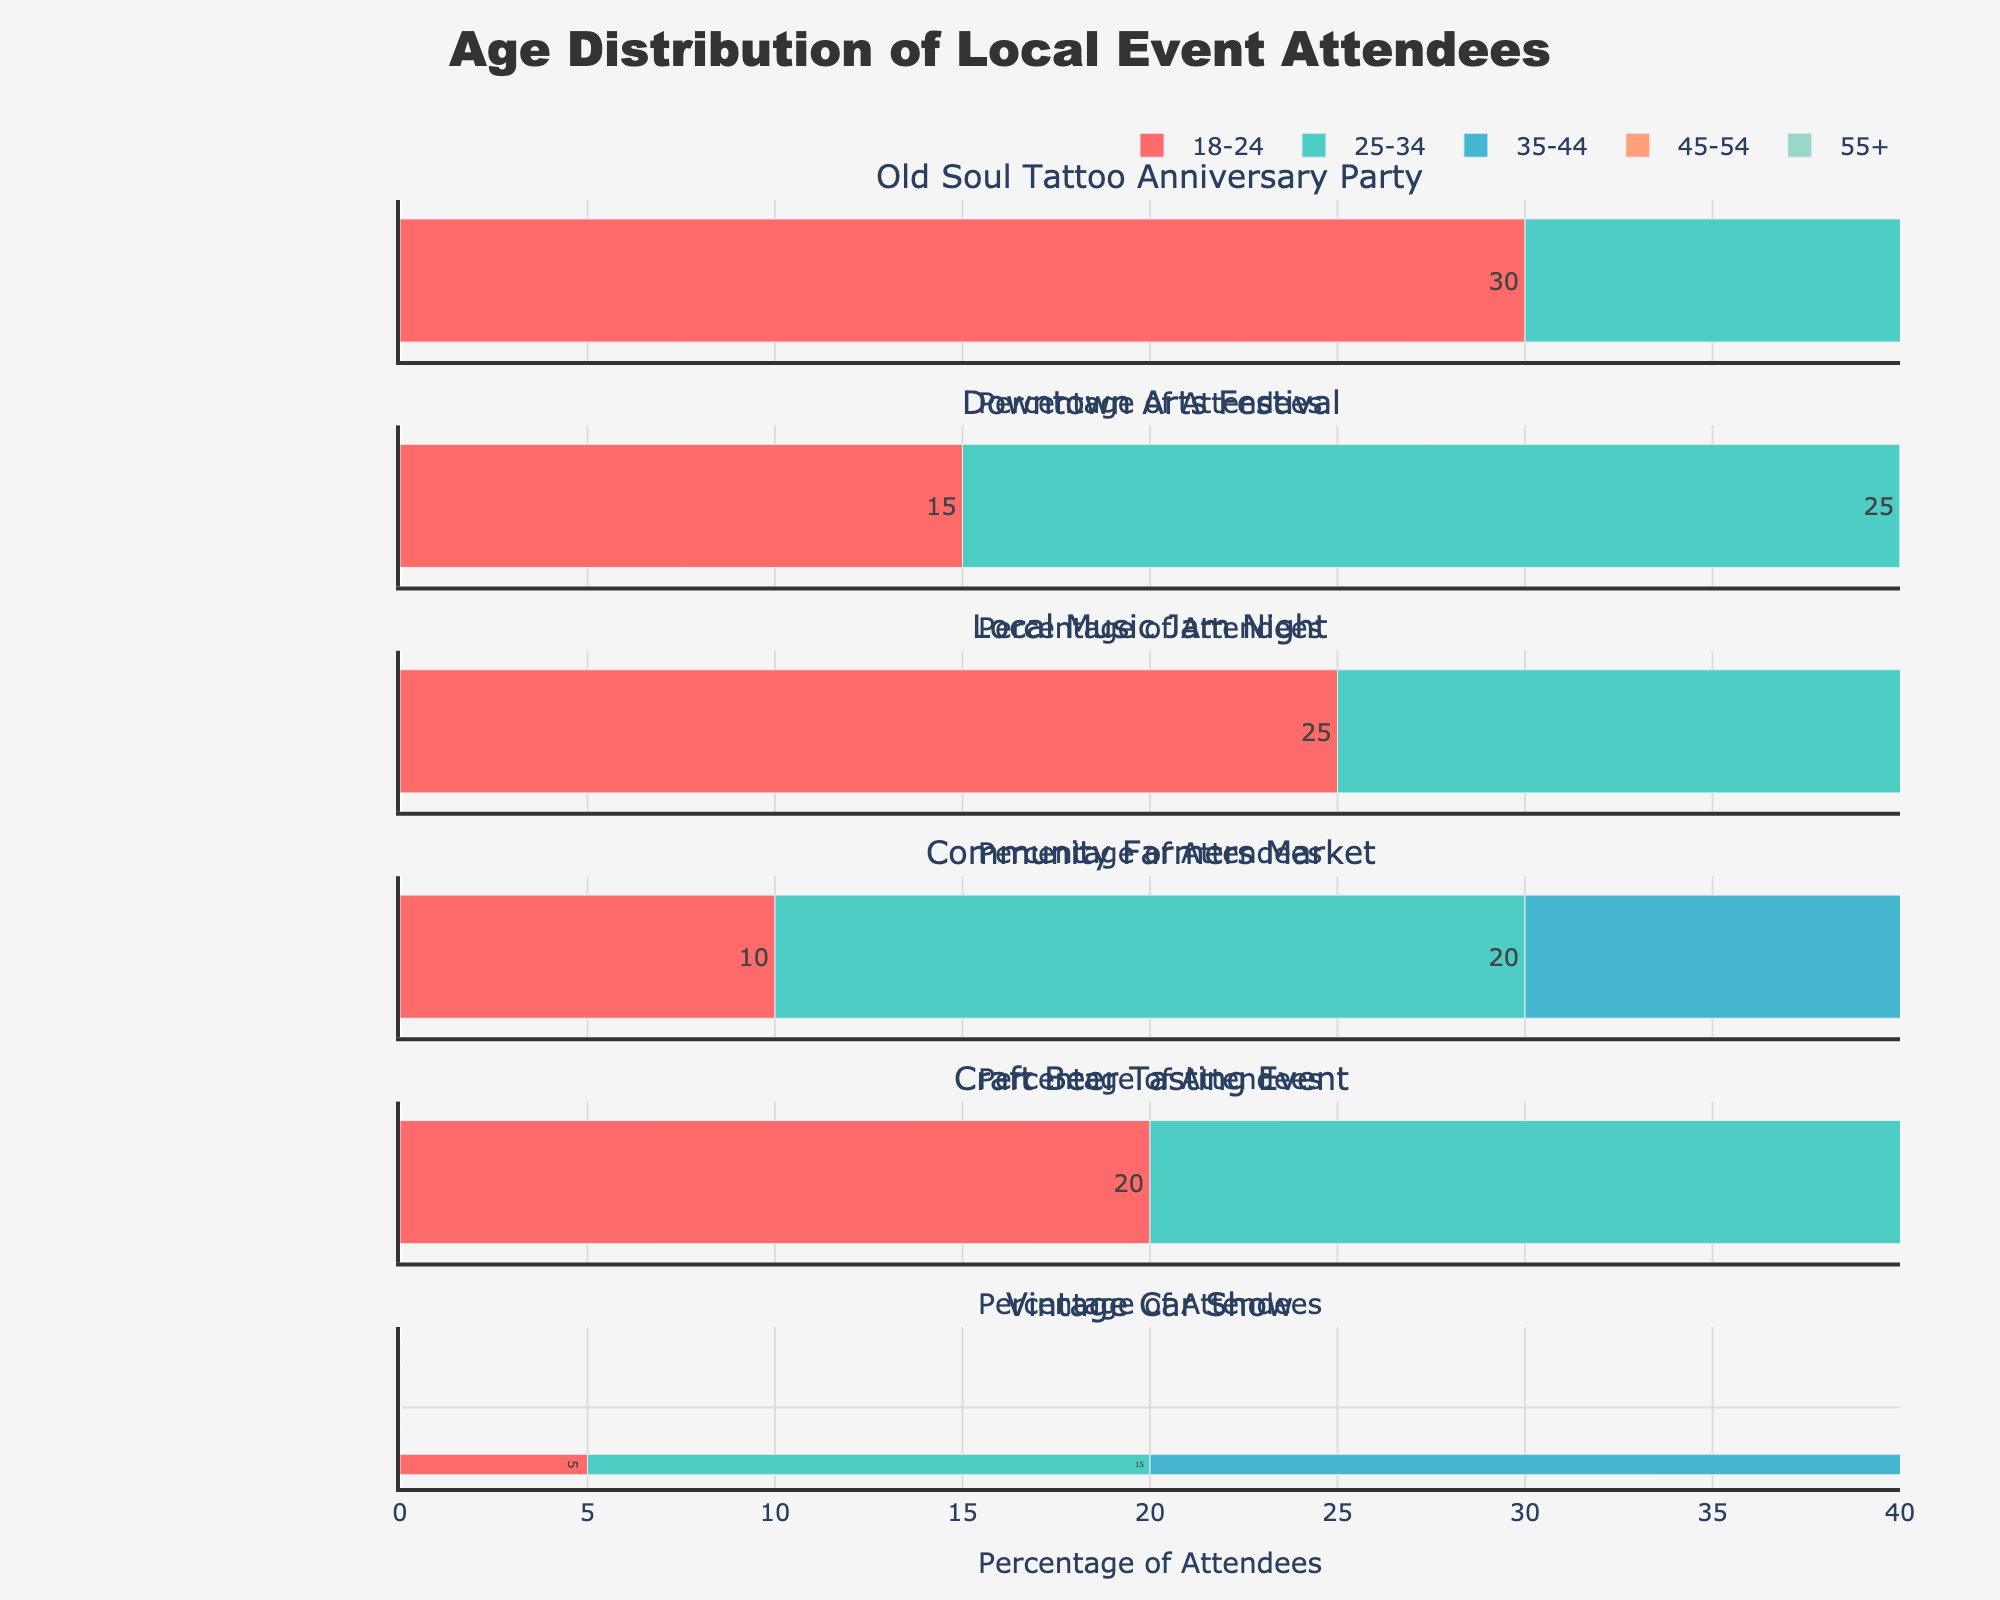What is the total number of TV roles Keremcem has played in Drama and Comedy genres? To find the total number of TV roles in Drama and Comedy, add the number of roles in these genres. Drama: 8 roles, Comedy: 5 roles. Adding them together: 8 + 5 = 13
Answer: 13 Which medium has the most acting roles in the Action genre? Look at the numbers in the Action column for each medium. TV has 2 roles, Film has 1 role, and Theater has 0 roles. Therefore, TV has the most roles in Action.
Answer: TV What genre has Keremcem acted the least in films? In the Film row, compare the values for each genre. The Historical genre has the lowest value of 0.
Answer: Historical In which medium does Keremcem have the highest number of roles in the Romance genre, and how many are there? Look at the values in the Romance column for each medium. Film has 4 roles, which is higher than TV (6 roles) and Theater (1 role).
Answer: TV, 6 What is the average number of roles Keremcem has played across all genres in Theater? Combine the total number of roles in Theater across all genres (Drama: 2, Comedy: 1, Romance: 1, Action: 0, Historical: 1) and divide by the number of genres. Total roles = 2 + 1 + 1 + 0 + 1 = 5. Number of genres = 5. Average = 5 / 5 = 1
Answer: 1 How many more TV roles does Keremcem have in Drama compared to Theater? To determine the difference, subtract the number of Theater roles in Drama from the number of TV roles in Drama. TV roles in Drama: 8, Theater roles in Drama: 2. Difference = 8 - 2 = 6
Answer: 6 Which genre has the highest representation in the Sunburst chart? The Sunburst chart shows values for each genre, and Drama has the highest total across all mediums with 13 roles (8 in TV + 3 in Film + 2 in Theater).
Answer: Drama What is the title of the entire figure? The title is displayed prominently at the top of the figure.
Answer: Keremcem's Acting Roles Breakdown Within the pie chart, which genre represents the smallest slice, and what is the corresponding value? In the Film Roles pie chart, the smallest slice represents Historical with a value of 0.
Answer: Historical, 0 How many genres are represented in the scatter plot for Theater roles? The scatter plot points have markers for each genre. Counting them gives 5 genres: Drama, Comedy, Romance, Action, and Historical.
Answer: 5 